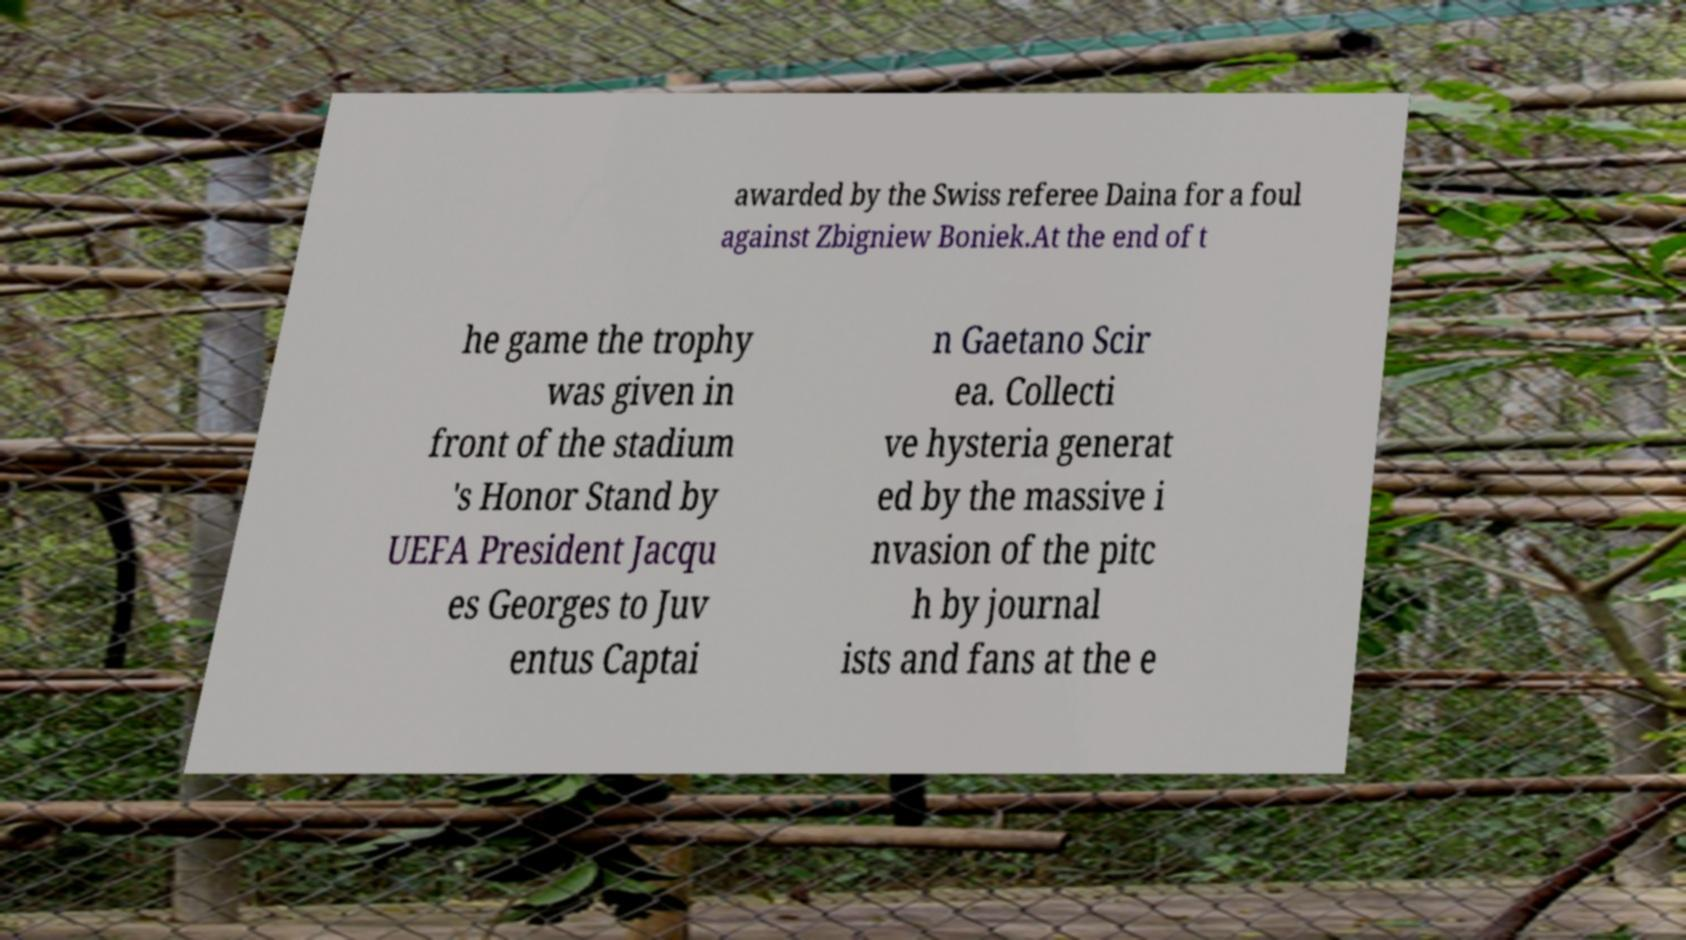I need the written content from this picture converted into text. Can you do that? awarded by the Swiss referee Daina for a foul against Zbigniew Boniek.At the end of t he game the trophy was given in front of the stadium 's Honor Stand by UEFA President Jacqu es Georges to Juv entus Captai n Gaetano Scir ea. Collecti ve hysteria generat ed by the massive i nvasion of the pitc h by journal ists and fans at the e 